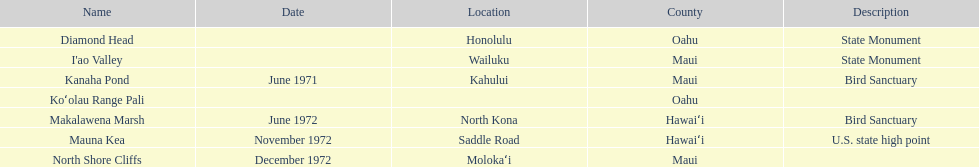What is the title of the unique landmark that also serves as a u.s. state high point? Mauna Kea. 